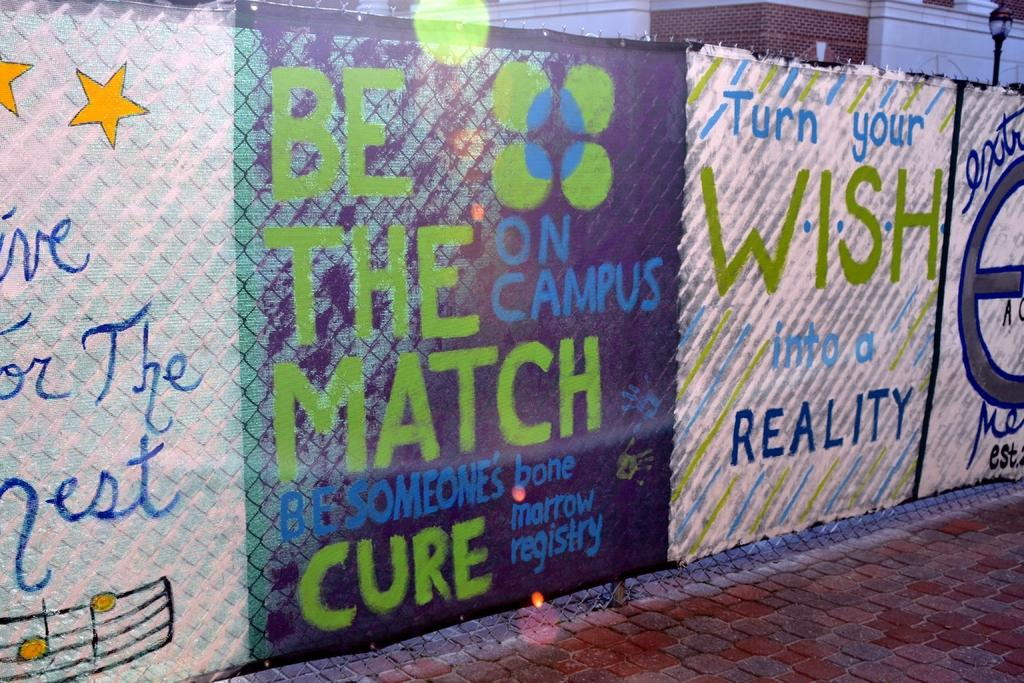<image>
Present a compact description of the photo's key features. A sign that says Turn Your Wish Into a Reality 